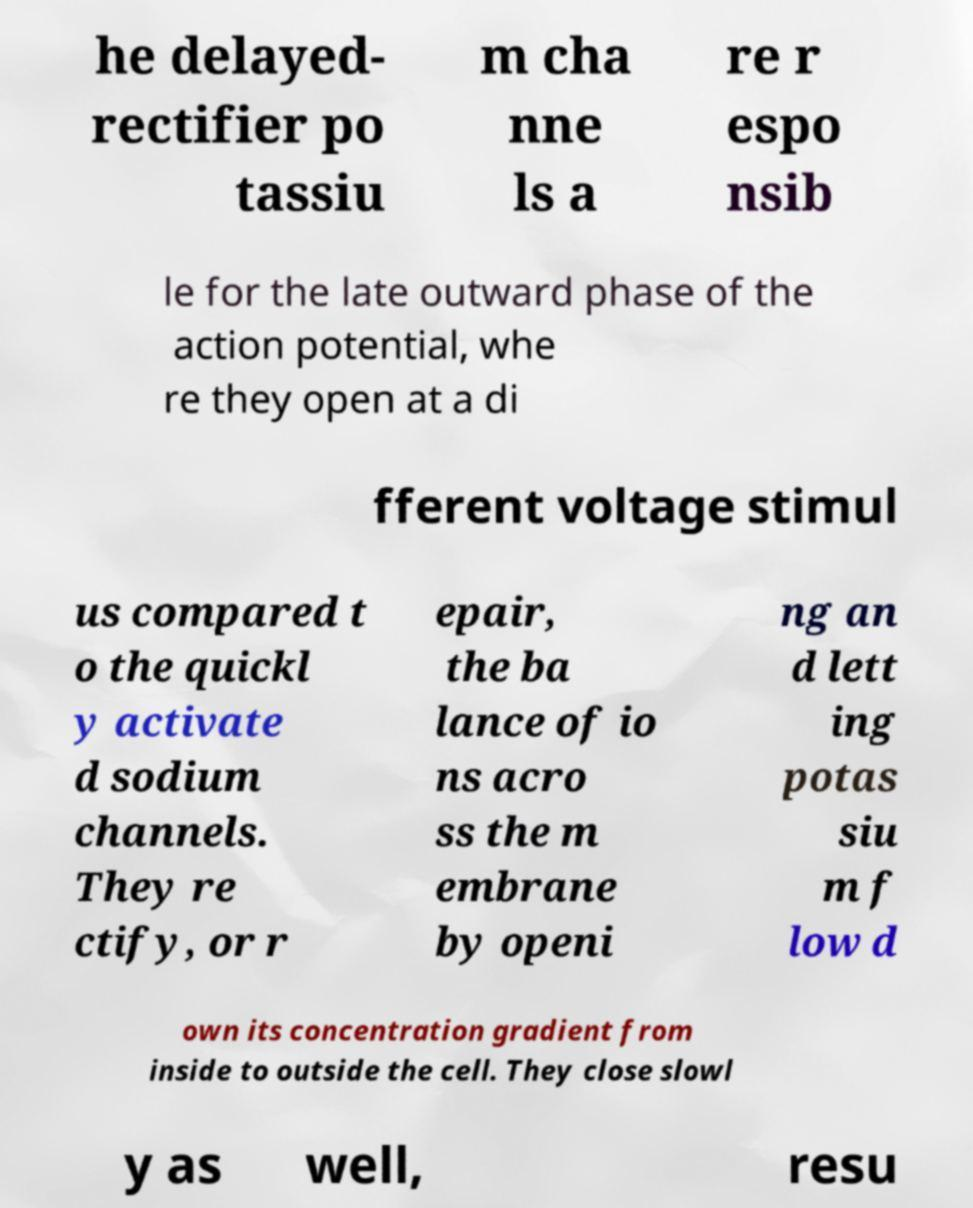Please read and relay the text visible in this image. What does it say? he delayed- rectifier po tassiu m cha nne ls a re r espo nsib le for the late outward phase of the action potential, whe re they open at a di fferent voltage stimul us compared t o the quickl y activate d sodium channels. They re ctify, or r epair, the ba lance of io ns acro ss the m embrane by openi ng an d lett ing potas siu m f low d own its concentration gradient from inside to outside the cell. They close slowl y as well, resu 